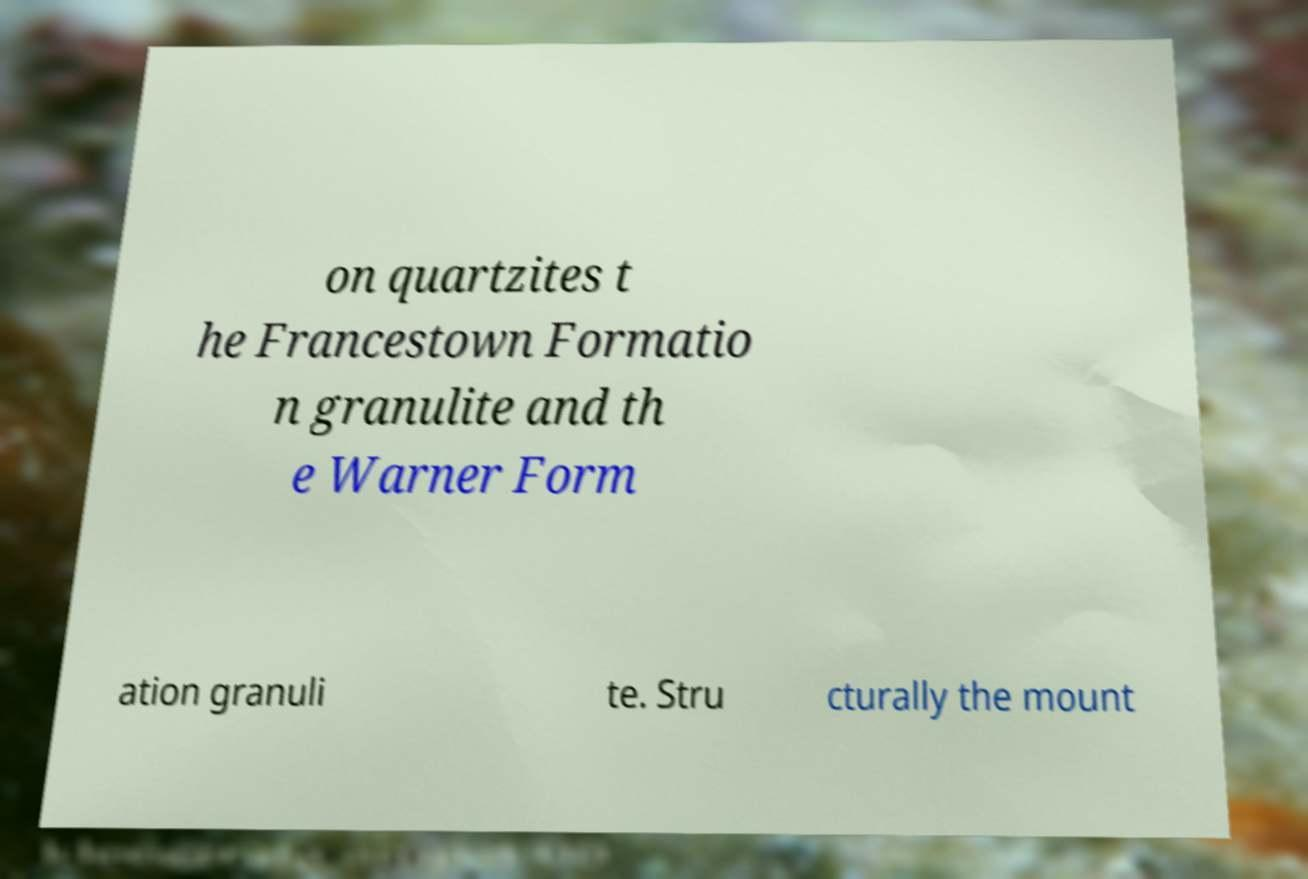Please read and relay the text visible in this image. What does it say? on quartzites t he Francestown Formatio n granulite and th e Warner Form ation granuli te. Stru cturally the mount 